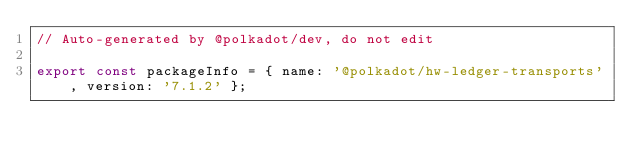<code> <loc_0><loc_0><loc_500><loc_500><_TypeScript_>// Auto-generated by @polkadot/dev, do not edit

export const packageInfo = { name: '@polkadot/hw-ledger-transports', version: '7.1.2' };
</code> 